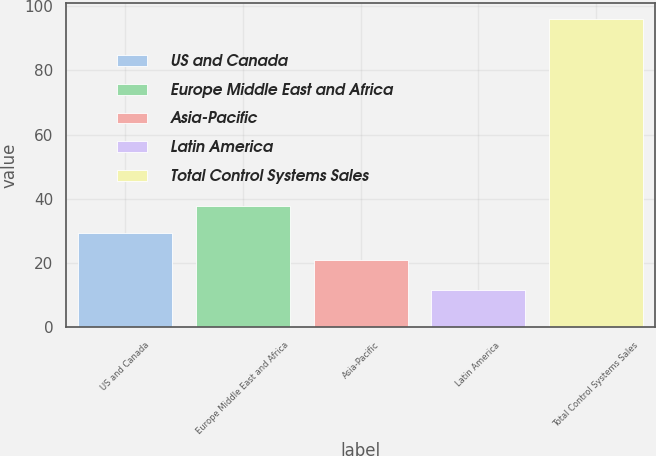Convert chart to OTSL. <chart><loc_0><loc_0><loc_500><loc_500><bar_chart><fcel>US and Canada<fcel>Europe Middle East and Africa<fcel>Asia-Pacific<fcel>Latin America<fcel>Total Control Systems Sales<nl><fcel>29.36<fcel>37.82<fcel>20.9<fcel>11.5<fcel>96.1<nl></chart> 